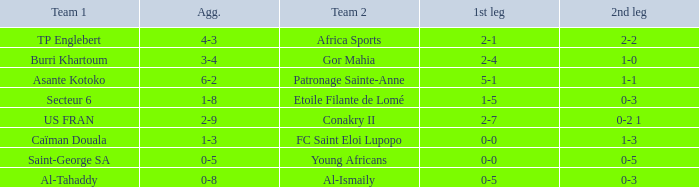Which team lost 0-3 and 0-5? Al-Tahaddy. 